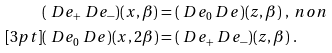<formula> <loc_0><loc_0><loc_500><loc_500>& ( \ D e _ { + } \ D e _ { - } ) ( x , \beta ) = ( \ D e _ { 0 } \ D e ) ( z , \beta ) \ , \ n o n \\ [ 3 p t ] & ( \ D e _ { 0 } \ D e ) ( x , 2 \beta ) = ( \ D e _ { + } \ D e _ { - } ) ( z , \beta ) \ .</formula> 